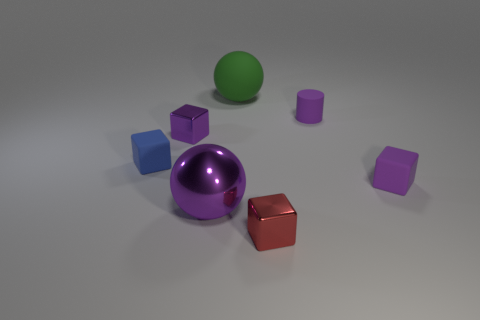How do the materials of the objects in the image differ from one another? The objects in the image display a variety of surface textures and reflectivities, suggesting differences in material. The green sphere appears to have a matte, slightly textured surface, consistent with rubber. The purple object has a shiny metallic finish, and the red and blue objects, which resemble cubes, seem to have a plastic-like sheen. 